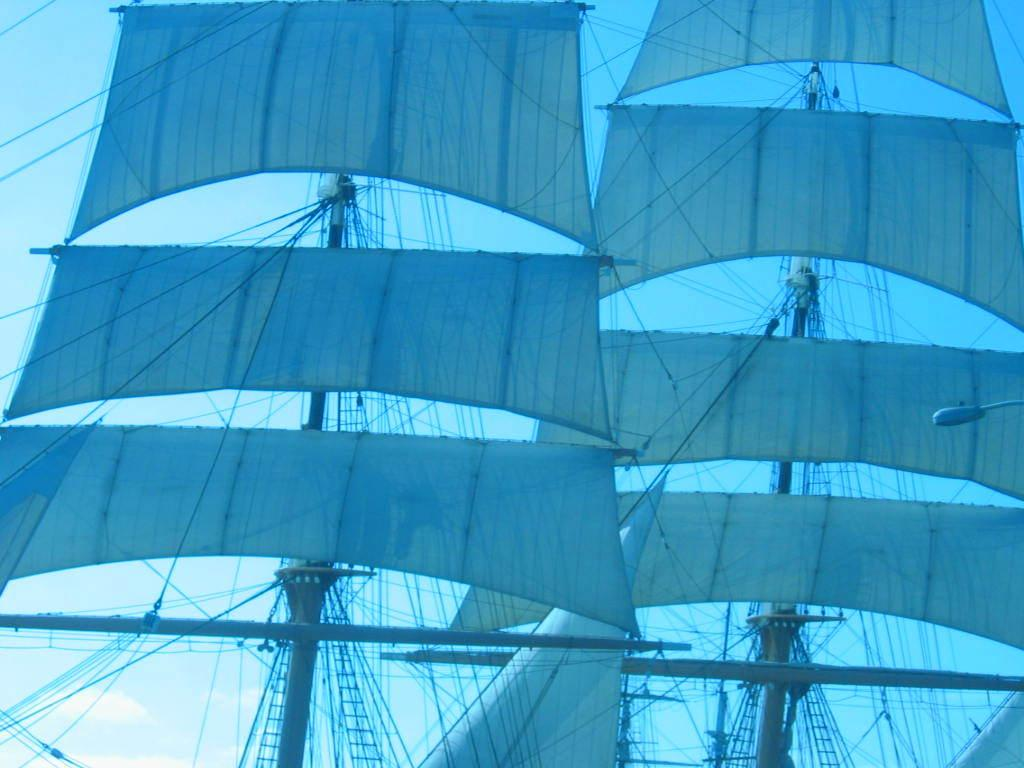What type of vehicles can be seen in the image? There are ships in the image. What are the ship wires used for? The ship wires are used to connect and support the ships. What is the purpose of the street light in the image? The street light provides illumination in the area. What type of organization is responsible for the tray in the image? There is no tray present in the image, so it is not possible to determine which organization might be responsible for it. 